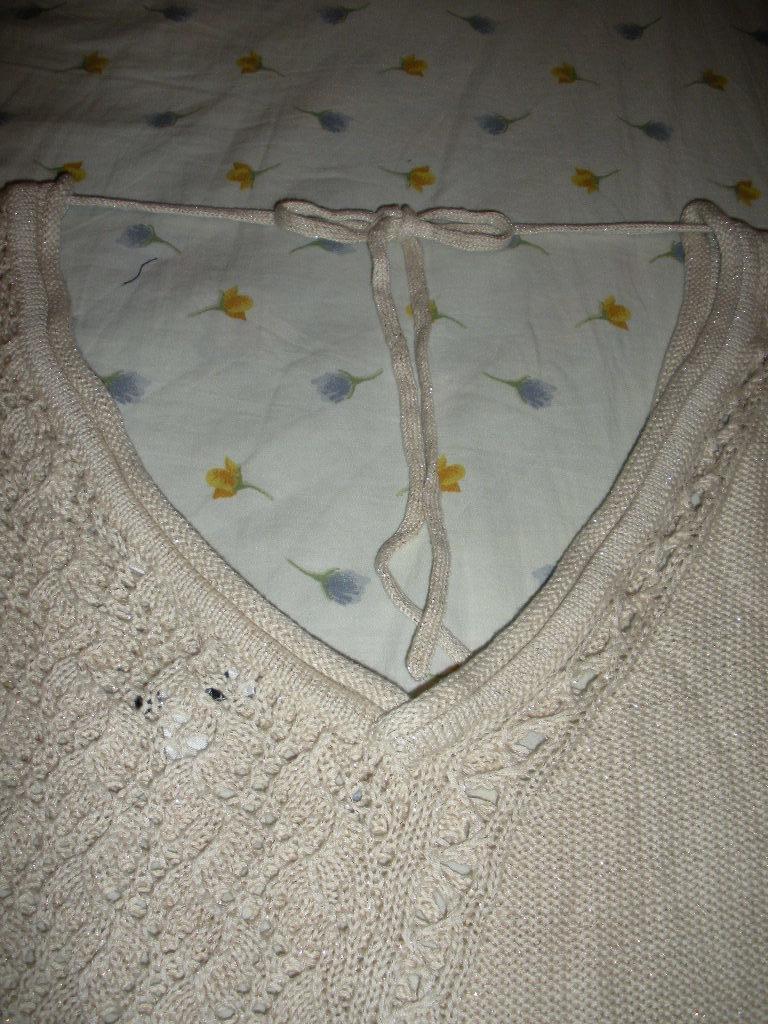Please provide a concise description of this image. In this image, we can see woolen cloth with threads on the white cloth. 